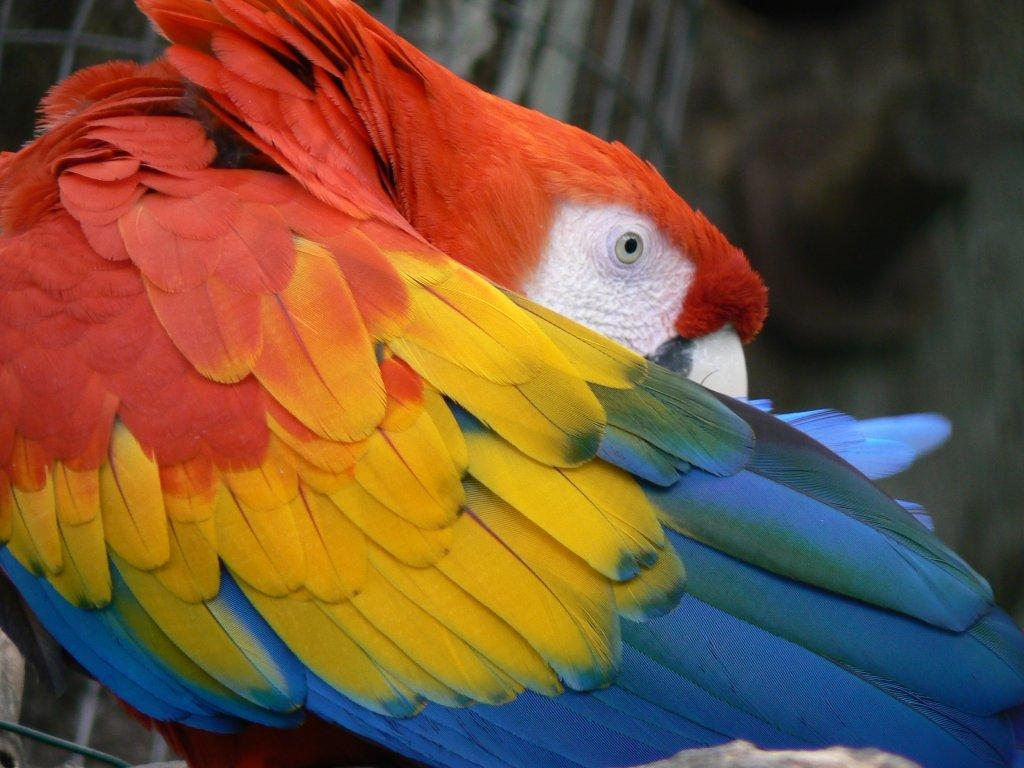What type of animal is in the image? There is a bird in the image. Can you describe the background of the image? The background of the image is blurry. How many cherries can be seen on the bird in the image? There are no cherries present in the image, and the bird is not interacting with any cherries. 